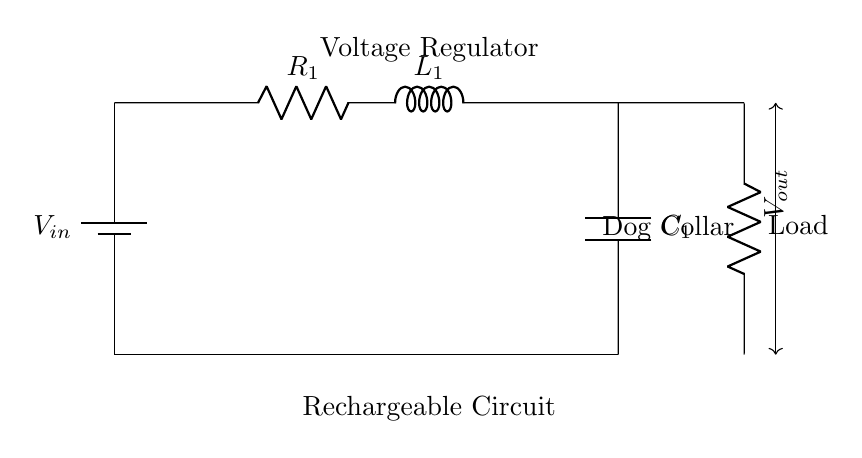What is the input voltage in the circuit? The input voltage is represented by the label V_{in} next to the battery symbol in the diagram. This indicates the source of power for the circuit.
Answer: V_{in} What component is used to limit current in this circuit? The component that limits current in the circuit is the resistor labeled R_{1}, which is connected between the voltage input and the inductor.
Answer: R_{1} What is the purpose of the inductor in this circuit? The inductor L_{1} is utilized to store energy in a magnetic field and can smooth out fluctuations in current, which is critical for providing stable voltage output for the load.
Answer: To store energy What is connected to the output of this circuit? The output of the circuit is connected to a load, which in this case is labeled as "Load" on the diagram; it signifies the dog collar that requires power.
Answer: Load What component is located at the bottom of the circuit? The component located at the bottom of the circuit diagram is the capacitor labeled C_{1}, which is placed parallel to the output to stabilize voltage.
Answer: C_{1} What does the voltage regulator do in this circuit? The voltage regulator adjusts the voltage levels to ensure that the output voltage V_{out} remains stable and within the required range for charging the rechargeable dog collar.
Answer: Stabilize voltage What is the purpose of the ground connection in this circuit? The ground connection serves as a return path for current and provides a common reference point for the circuit components, ensuring the safety and proper operation of the circuit.
Answer: Common reference 